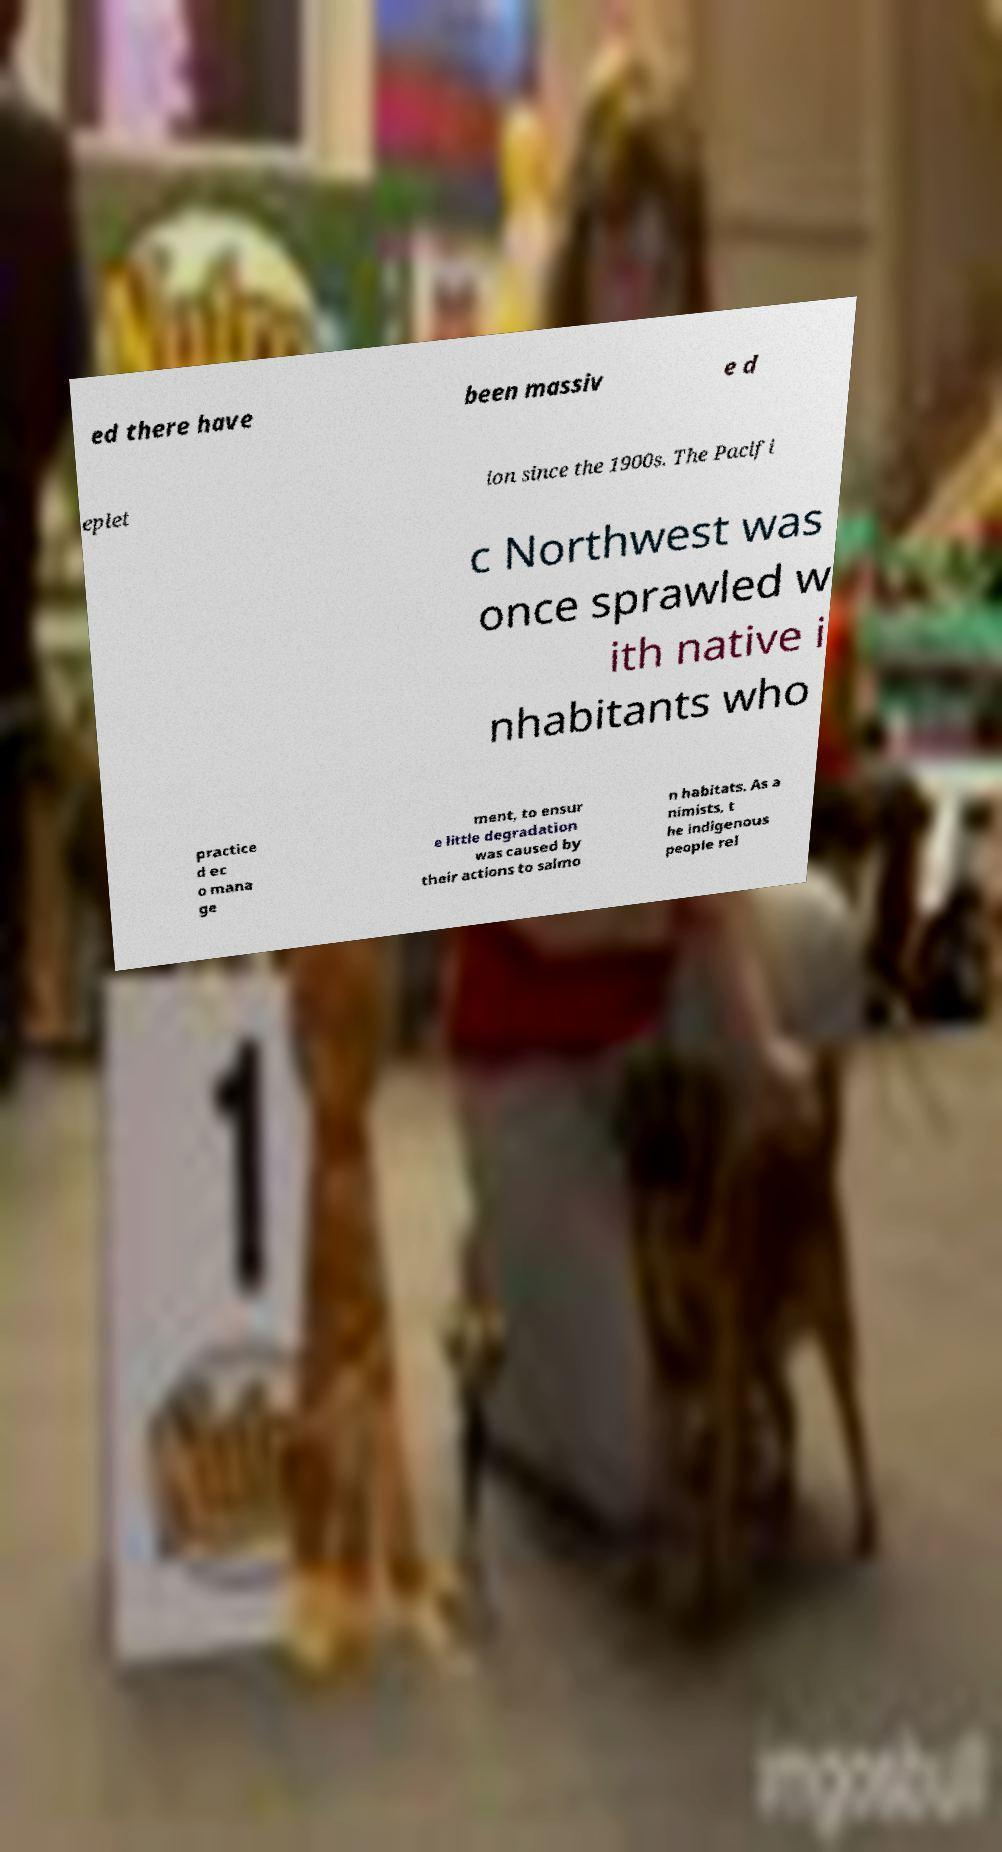Please identify and transcribe the text found in this image. ed there have been massiv e d eplet ion since the 1900s. The Pacifi c Northwest was once sprawled w ith native i nhabitants who practice d ec o mana ge ment, to ensur e little degradation was caused by their actions to salmo n habitats. As a nimists, t he indigenous people rel 